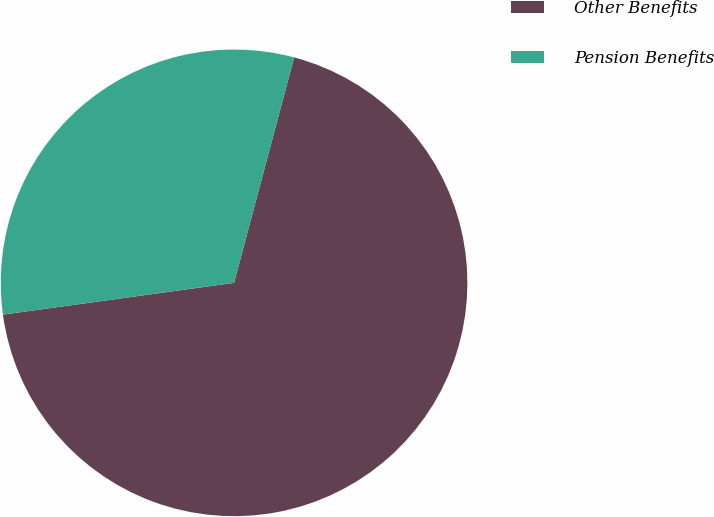<chart> <loc_0><loc_0><loc_500><loc_500><pie_chart><fcel>Other Benefits<fcel>Pension Benefits<nl><fcel>68.68%<fcel>31.32%<nl></chart> 